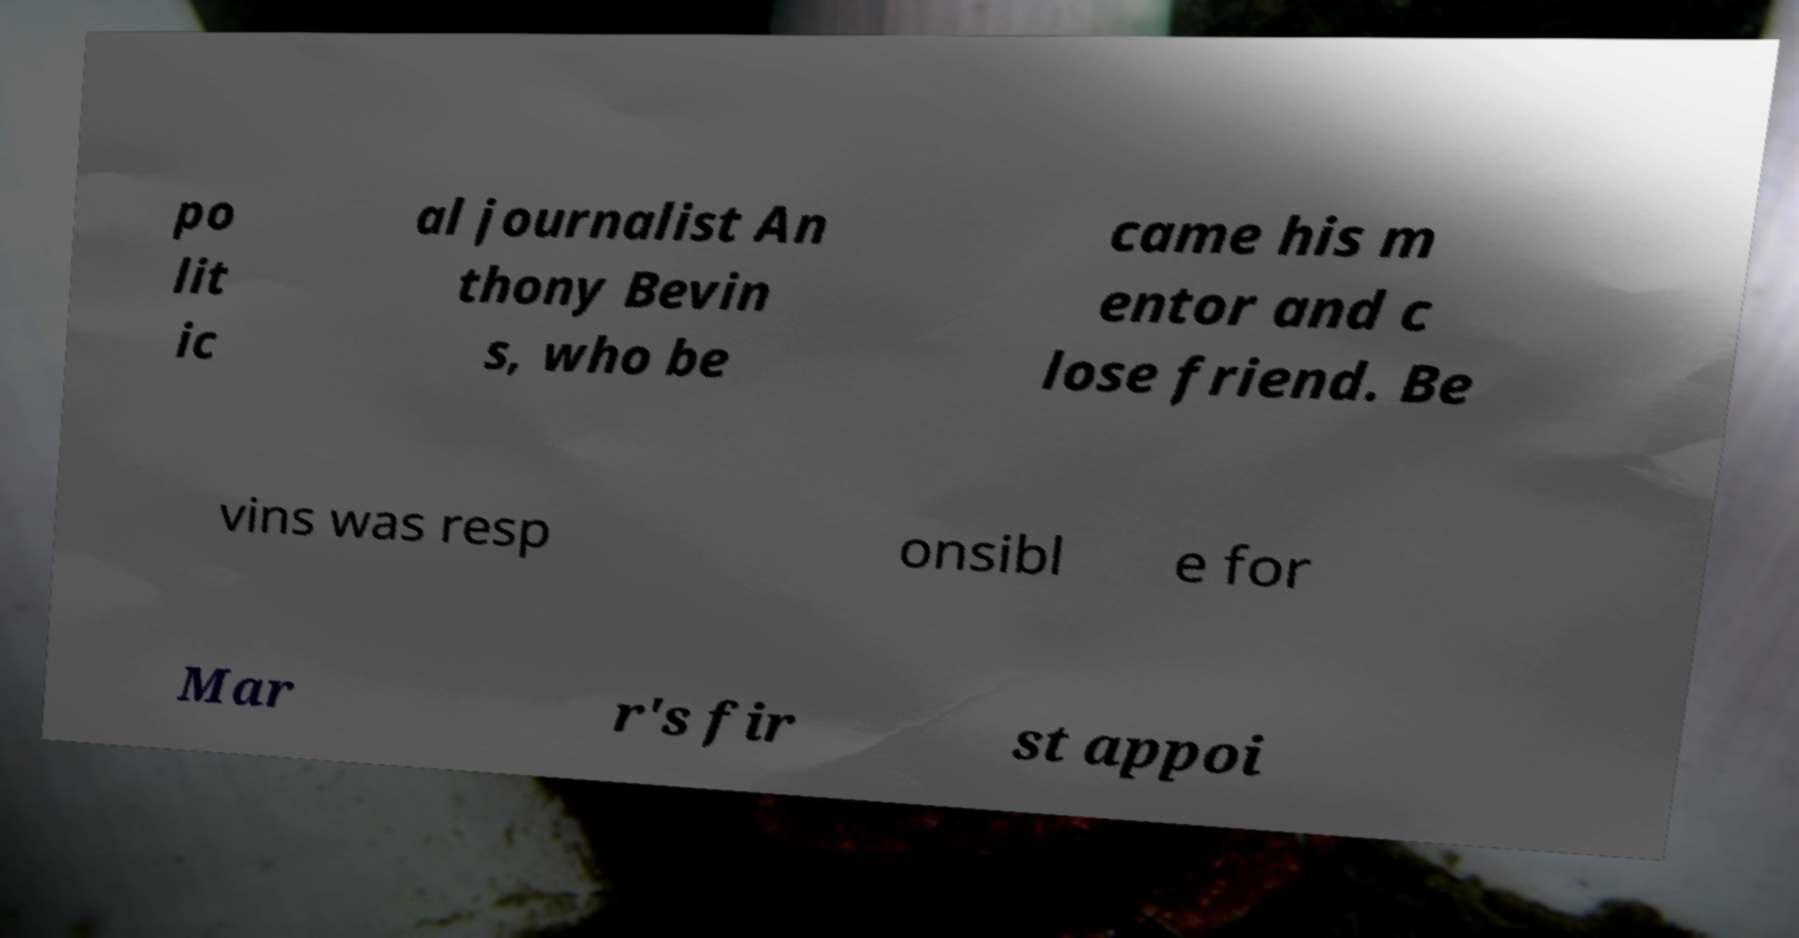Can you accurately transcribe the text from the provided image for me? po lit ic al journalist An thony Bevin s, who be came his m entor and c lose friend. Be vins was resp onsibl e for Mar r's fir st appoi 